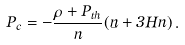Convert formula to latex. <formula><loc_0><loc_0><loc_500><loc_500>P _ { c } = - \frac { \rho + P _ { t h } } { n } ( \dot { n } + 3 H n ) \, .</formula> 